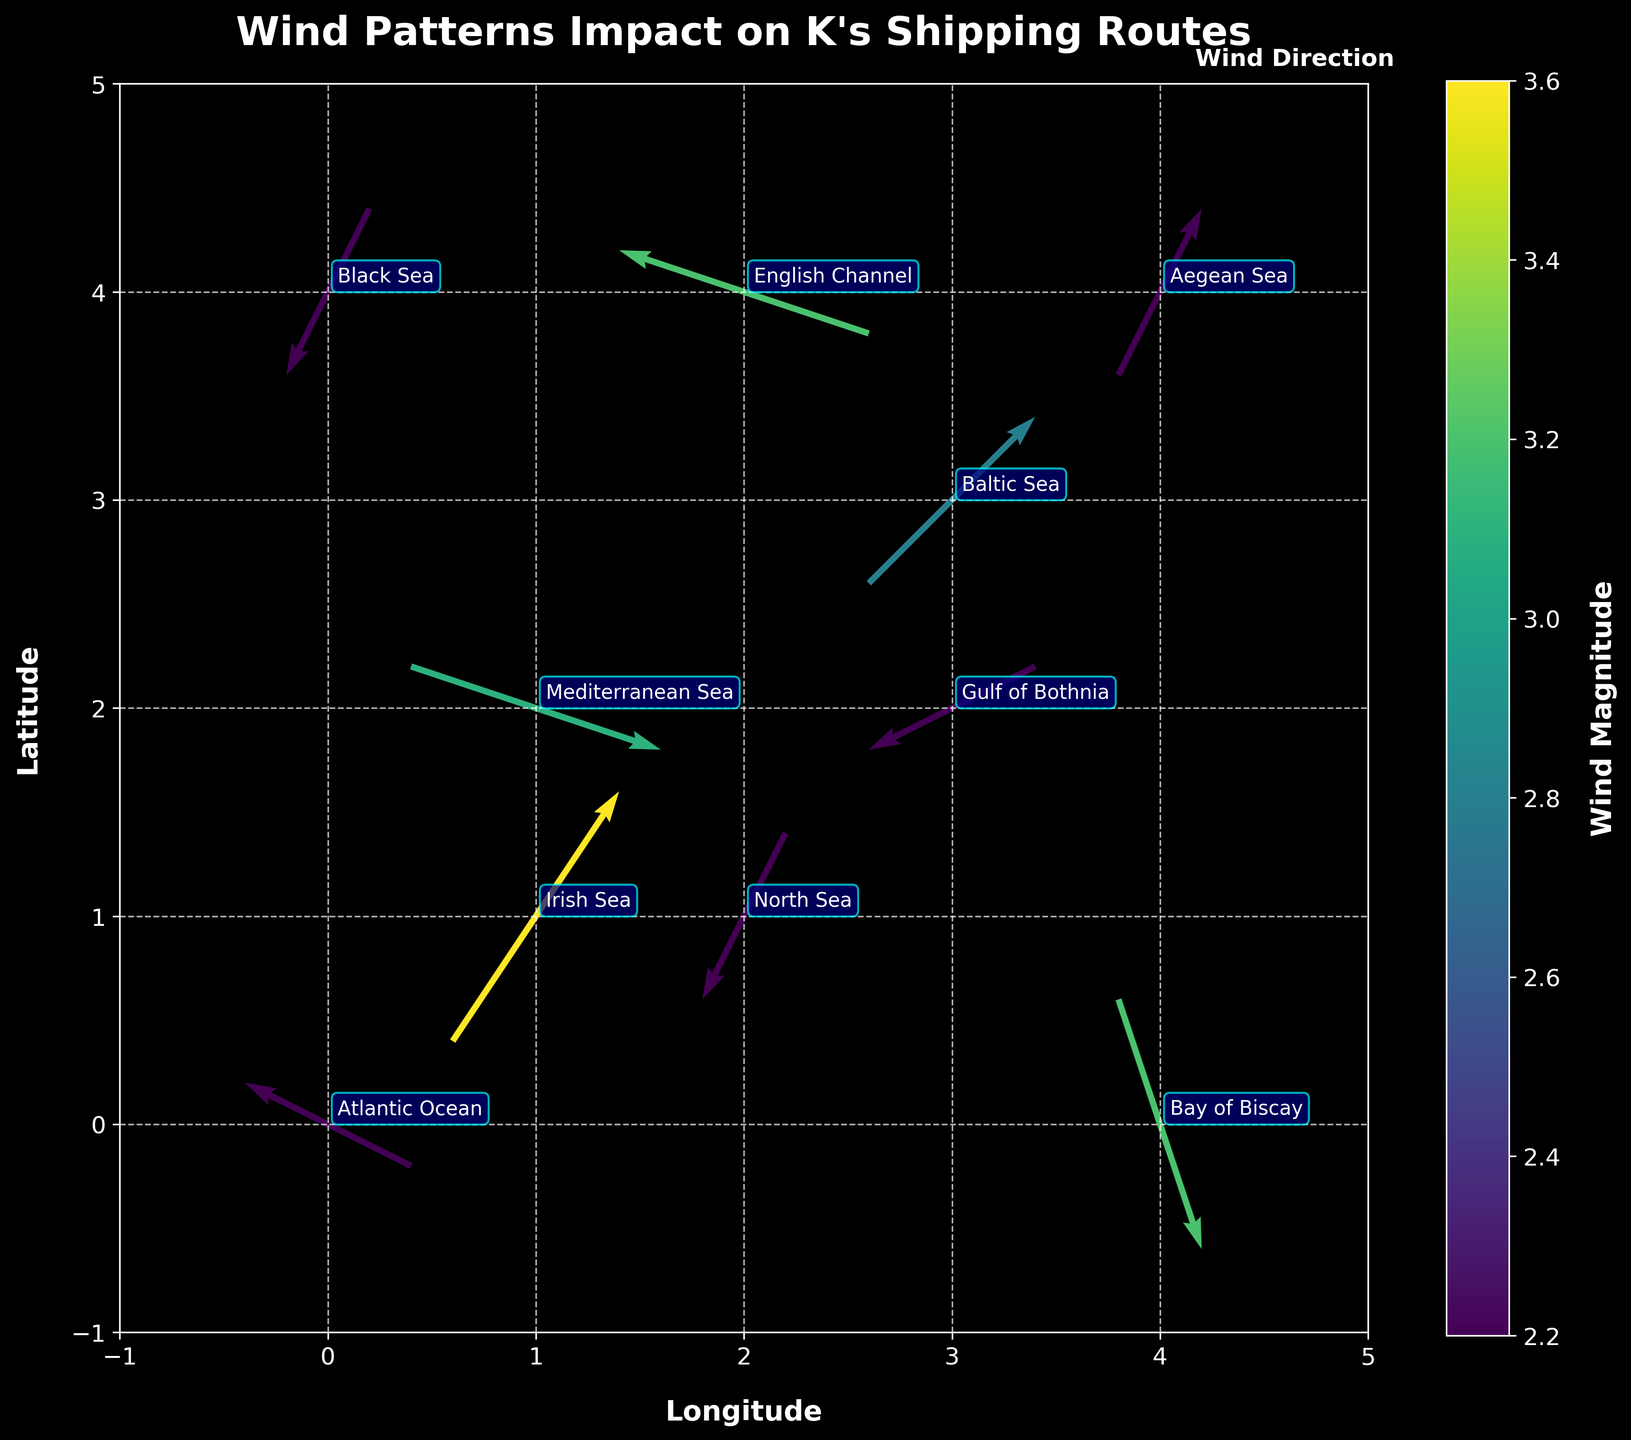What is the title of the plot? The title is displayed prominently at the top of the plot.
Answer: Wind Patterns Impact on K's Shipping Routes Which region is closest to the coordinates (2, 4)? The coordinates (2, 4) are near the "English Channel" label on the plot.
Answer: English Channel How many different regions are represented in the plot? Each label represents one region, and there are labels for 10 different regions on the plot.
Answer: 10 What is the wind direction at coordinates (4, 0)? The wind direction at (4, 0) is shown by the arrow pointing upward and slightly to the left.
Answer: Upward-left Which region experiences the strongest wind magnitude? Look for the longest arrows and check the color intensity representing magnitude, the longest arrow and most intense color are located at (1, 1) in the "Irish Sea".
Answer: Irish Sea Which regions have wind blowing towards the northeast direction? The northeast direction would mean arrows pointing towards the top-right. In the "Irish Sea," wind is blowing northeast.
Answer: Irish Sea Is the wind direction uniform across the "Gulf of Bothnia" and the "Baltic Sea"? Both regions need to be checked. The arrow in "Gulf of Bothnia" points southeast, while in the "Baltic Sea," the arrow points northeast.
Answer: No Compare the magnitude of wind in the "Bay of Biscay" and the "Aegean Sea." Which region has a higher magnitude? The color intensity of the arrows shows the magnitude. In the plot, "Bay of Biscay" has a more intense color than "Aegean Sea."
Answer: Bay of Biscay From the "Atlantic Ocean" region, which direction is the wind blowing? Check the arrow from the "Atlantic Ocean" region; it points upwards and to the right.
Answer: Upward-right What is the relationship between wind magnitude and color intensity on the plot? Higher wind magnitudes are depicted with more intense colors, as indicated by the color bar.
Answer: More intense color represents higher magnitude 